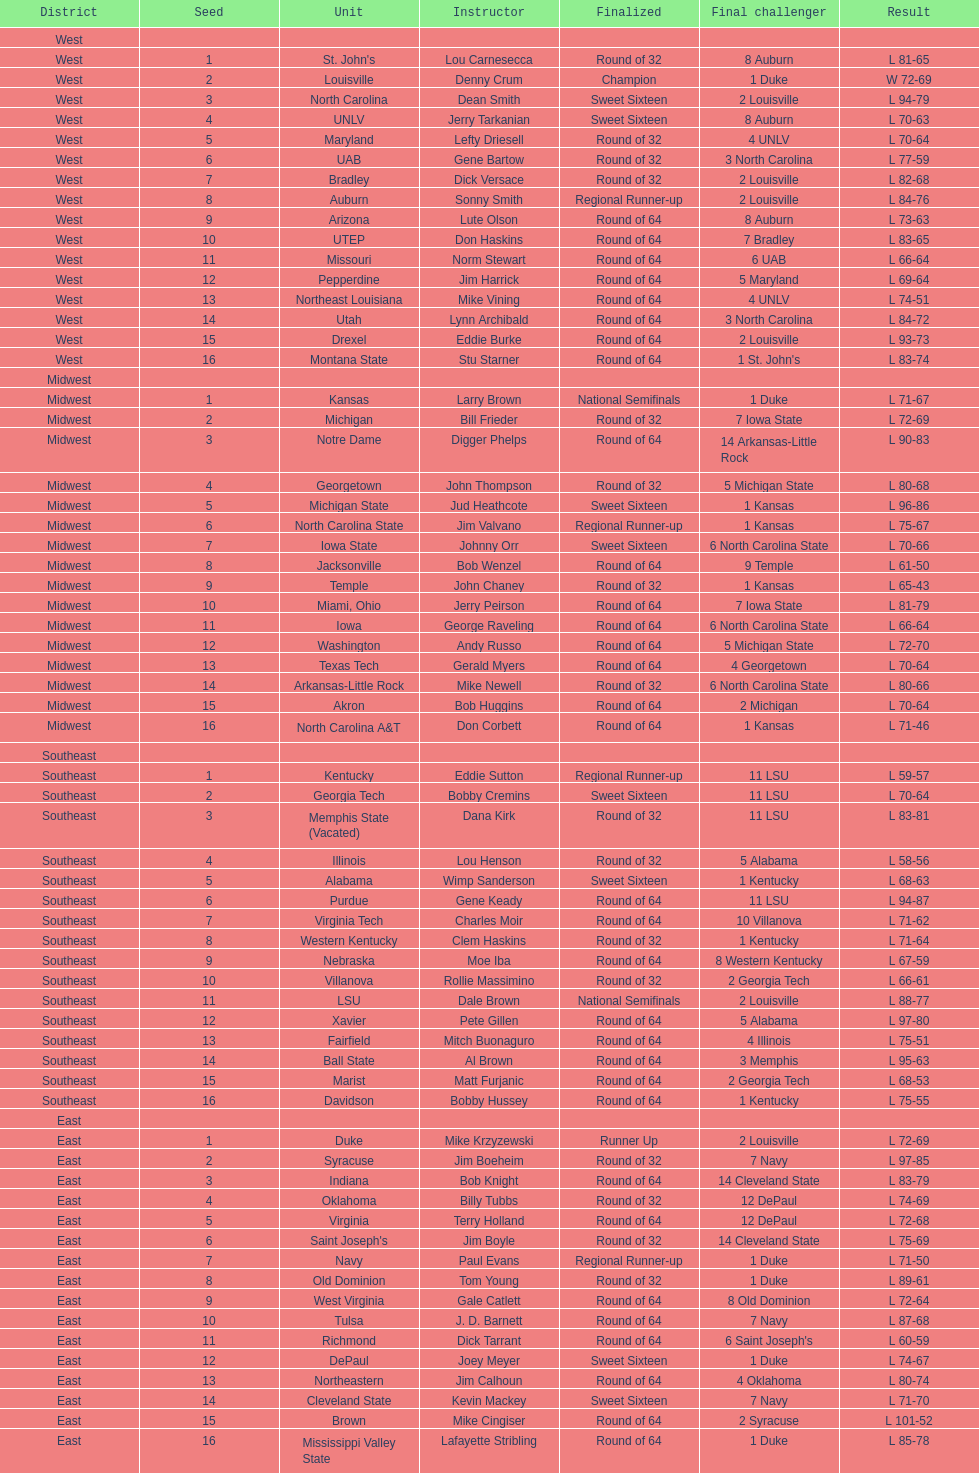Who is the only team from the east region to reach the final round? Duke. 